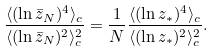<formula> <loc_0><loc_0><loc_500><loc_500>\frac { \langle ( \ln \bar { z } _ { N } ) ^ { 4 } \rangle _ { c } } { \langle ( \ln \bar { z } _ { N } ) ^ { 2 } \rangle _ { c } ^ { 2 } } = \frac { 1 } { N } \frac { \langle ( \ln z _ { \ast } ) ^ { 4 } \rangle _ { c } } { \langle ( \ln z _ { \ast } ) ^ { 2 } \rangle _ { c } ^ { 2 } } .</formula> 